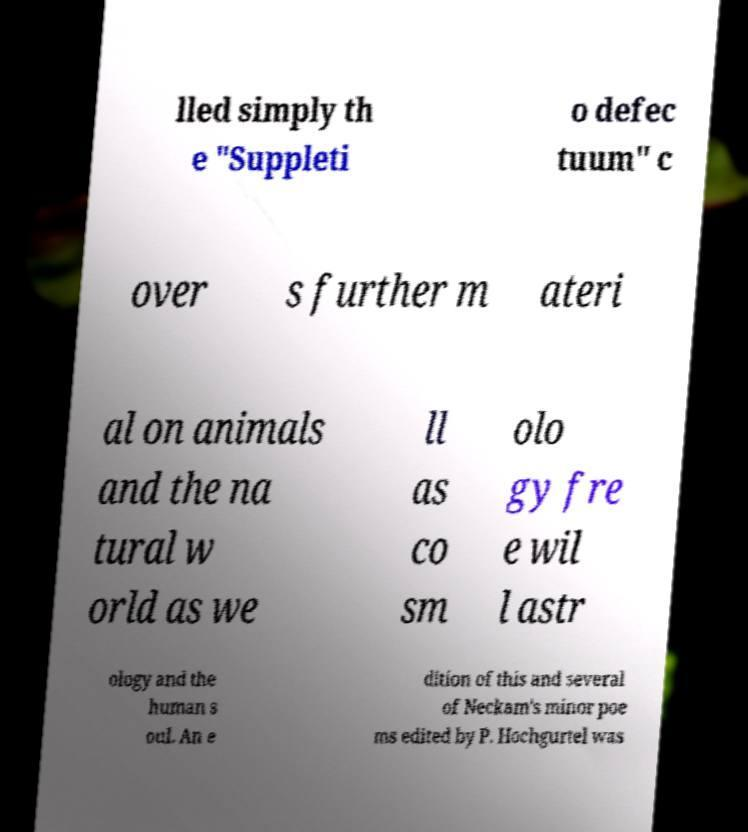Could you assist in decoding the text presented in this image and type it out clearly? lled simply th e "Suppleti o defec tuum" c over s further m ateri al on animals and the na tural w orld as we ll as co sm olo gy fre e wil l astr ology and the human s oul. An e dition of this and several of Neckam's minor poe ms edited by P. Hochgurtel was 